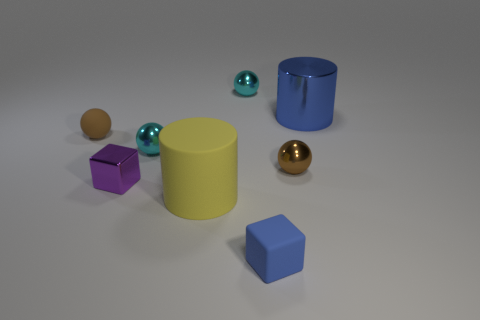Subtract all matte spheres. How many spheres are left? 3 Subtract 1 spheres. How many spheres are left? 3 Add 1 tiny cyan shiny cylinders. How many objects exist? 9 Subtract all green balls. Subtract all blue cubes. How many balls are left? 4 Subtract all cubes. How many objects are left? 6 Subtract 0 green cylinders. How many objects are left? 8 Subtract all large blue cylinders. Subtract all small blue things. How many objects are left? 6 Add 5 small rubber blocks. How many small rubber blocks are left? 6 Add 6 large cylinders. How many large cylinders exist? 8 